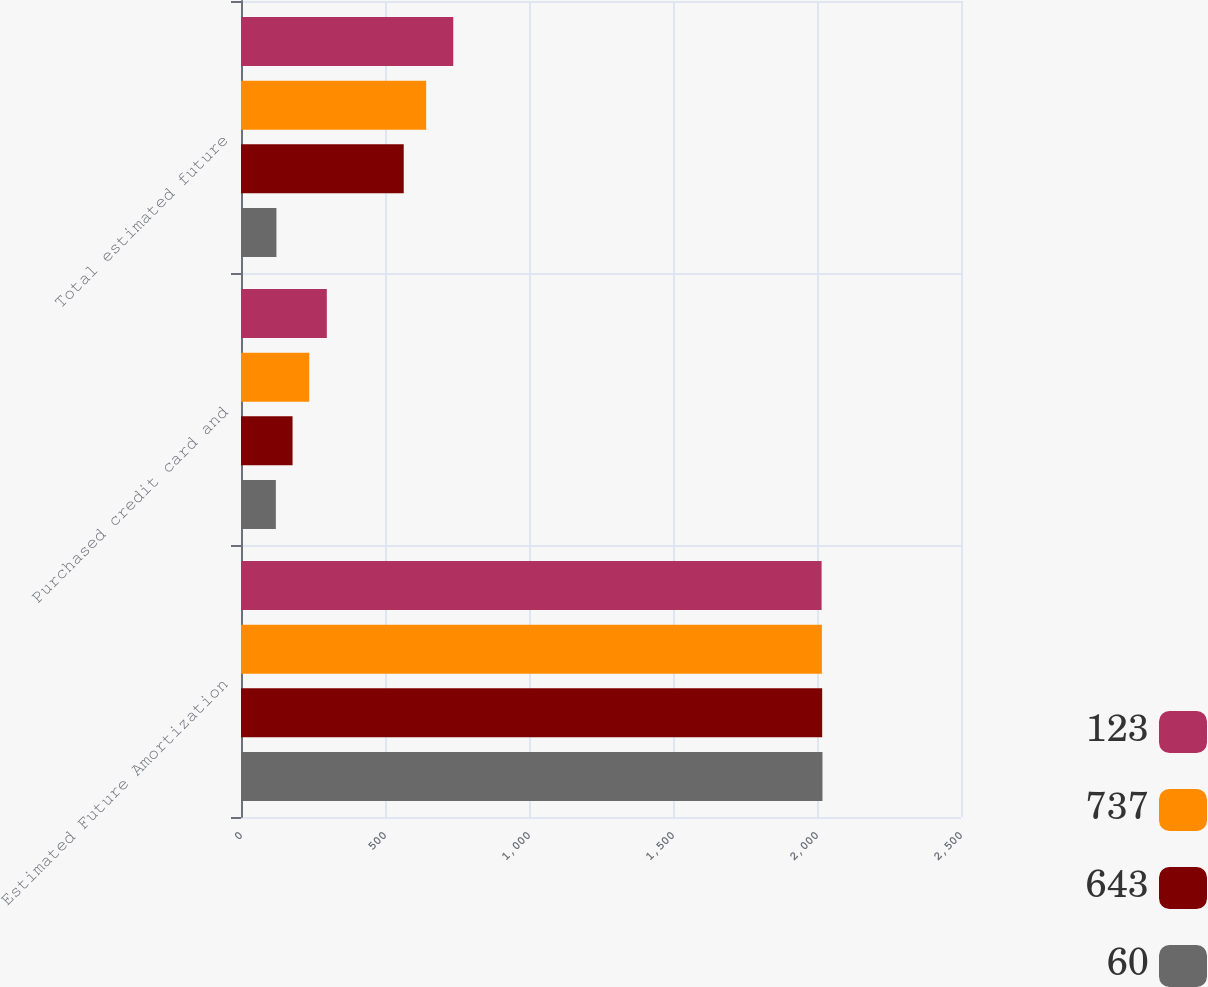Convert chart to OTSL. <chart><loc_0><loc_0><loc_500><loc_500><stacked_bar_chart><ecel><fcel>Estimated Future Amortization<fcel>Purchased credit card and<fcel>Total estimated future<nl><fcel>123<fcel>2016<fcel>298<fcel>737<nl><fcel>737<fcel>2017<fcel>237<fcel>643<nl><fcel>643<fcel>2018<fcel>179<fcel>565<nl><fcel>60<fcel>2019<fcel>121<fcel>123<nl></chart> 